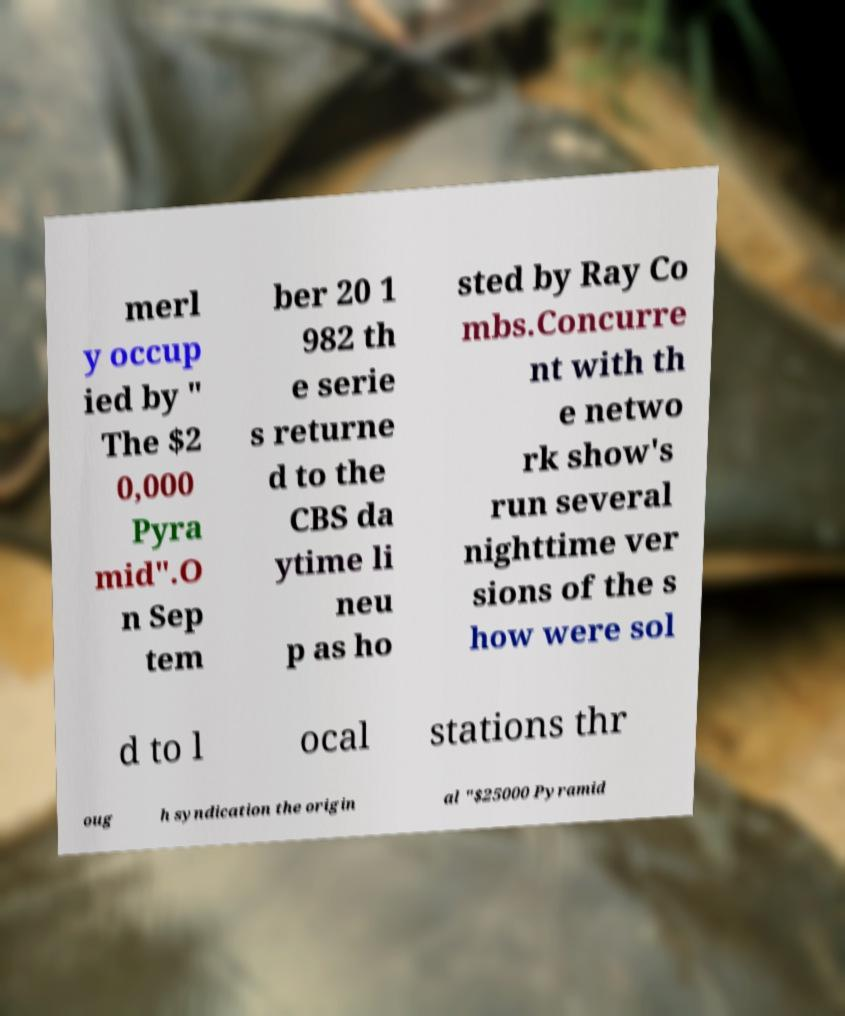I need the written content from this picture converted into text. Can you do that? merl y occup ied by " The $2 0,000 Pyra mid".O n Sep tem ber 20 1 982 th e serie s returne d to the CBS da ytime li neu p as ho sted by Ray Co mbs.Concurre nt with th e netwo rk show's run several nighttime ver sions of the s how were sol d to l ocal stations thr oug h syndication the origin al "$25000 Pyramid 